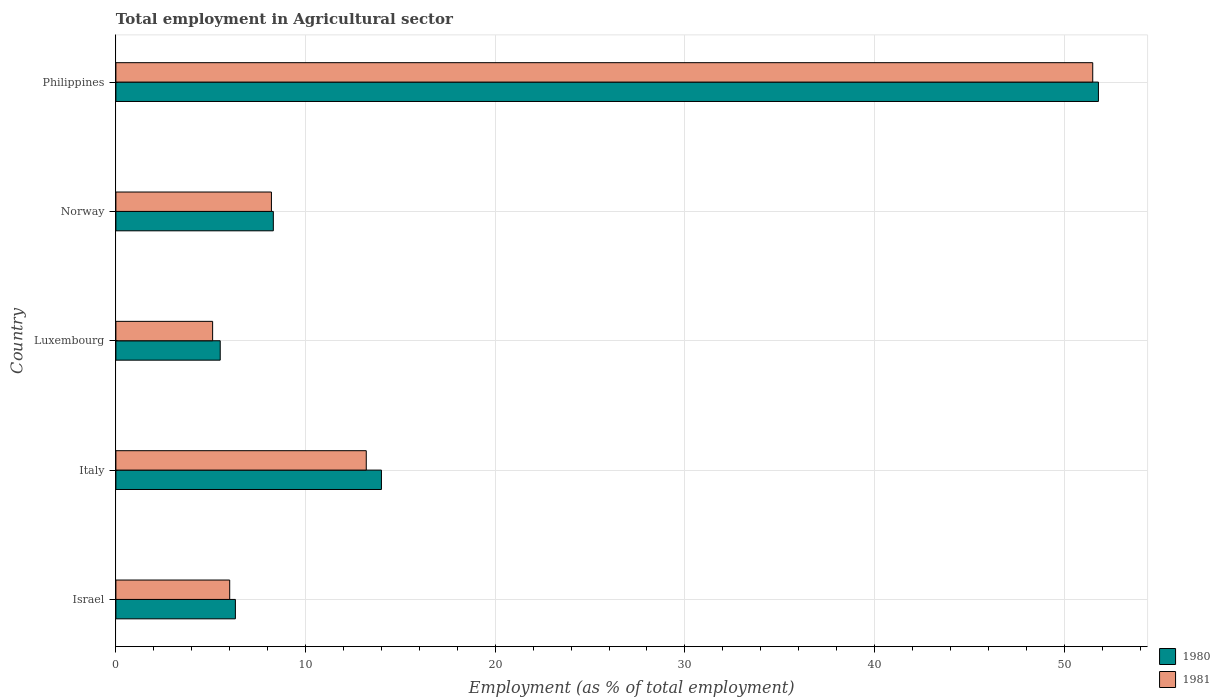How many different coloured bars are there?
Give a very brief answer. 2. How many groups of bars are there?
Provide a short and direct response. 5. Are the number of bars per tick equal to the number of legend labels?
Offer a terse response. Yes. How many bars are there on the 3rd tick from the top?
Ensure brevity in your answer.  2. What is the label of the 2nd group of bars from the top?
Your answer should be compact. Norway. In how many cases, is the number of bars for a given country not equal to the number of legend labels?
Your answer should be very brief. 0. What is the employment in agricultural sector in 1981 in Philippines?
Provide a succinct answer. 51.5. Across all countries, what is the maximum employment in agricultural sector in 1981?
Offer a terse response. 51.5. In which country was the employment in agricultural sector in 1981 maximum?
Offer a terse response. Philippines. In which country was the employment in agricultural sector in 1981 minimum?
Offer a terse response. Luxembourg. What is the total employment in agricultural sector in 1980 in the graph?
Provide a succinct answer. 85.9. What is the difference between the employment in agricultural sector in 1980 in Israel and that in Norway?
Your answer should be compact. -2. What is the difference between the employment in agricultural sector in 1980 in Italy and the employment in agricultural sector in 1981 in Norway?
Keep it short and to the point. 5.8. What is the average employment in agricultural sector in 1981 per country?
Offer a very short reply. 16.8. What is the difference between the employment in agricultural sector in 1981 and employment in agricultural sector in 1980 in Luxembourg?
Make the answer very short. -0.4. What is the ratio of the employment in agricultural sector in 1980 in Italy to that in Luxembourg?
Make the answer very short. 2.55. What is the difference between the highest and the second highest employment in agricultural sector in 1981?
Provide a short and direct response. 38.3. What is the difference between the highest and the lowest employment in agricultural sector in 1980?
Provide a succinct answer. 46.3. In how many countries, is the employment in agricultural sector in 1980 greater than the average employment in agricultural sector in 1980 taken over all countries?
Your answer should be very brief. 1. What does the 1st bar from the top in Israel represents?
Your response must be concise. 1981. What does the 2nd bar from the bottom in Luxembourg represents?
Give a very brief answer. 1981. How many bars are there?
Your answer should be compact. 10. Are all the bars in the graph horizontal?
Make the answer very short. Yes. What is the difference between two consecutive major ticks on the X-axis?
Ensure brevity in your answer.  10. Where does the legend appear in the graph?
Your answer should be very brief. Bottom right. How many legend labels are there?
Offer a terse response. 2. How are the legend labels stacked?
Ensure brevity in your answer.  Vertical. What is the title of the graph?
Provide a short and direct response. Total employment in Agricultural sector. What is the label or title of the X-axis?
Provide a succinct answer. Employment (as % of total employment). What is the Employment (as % of total employment) in 1980 in Israel?
Provide a succinct answer. 6.3. What is the Employment (as % of total employment) in 1980 in Italy?
Your response must be concise. 14. What is the Employment (as % of total employment) in 1981 in Italy?
Ensure brevity in your answer.  13.2. What is the Employment (as % of total employment) in 1981 in Luxembourg?
Provide a succinct answer. 5.1. What is the Employment (as % of total employment) in 1980 in Norway?
Offer a terse response. 8.3. What is the Employment (as % of total employment) in 1981 in Norway?
Make the answer very short. 8.2. What is the Employment (as % of total employment) of 1980 in Philippines?
Give a very brief answer. 51.8. What is the Employment (as % of total employment) in 1981 in Philippines?
Provide a short and direct response. 51.5. Across all countries, what is the maximum Employment (as % of total employment) in 1980?
Give a very brief answer. 51.8. Across all countries, what is the maximum Employment (as % of total employment) in 1981?
Offer a terse response. 51.5. Across all countries, what is the minimum Employment (as % of total employment) of 1981?
Your answer should be compact. 5.1. What is the total Employment (as % of total employment) in 1980 in the graph?
Give a very brief answer. 85.9. What is the total Employment (as % of total employment) in 1981 in the graph?
Provide a succinct answer. 84. What is the difference between the Employment (as % of total employment) of 1980 in Israel and that in Italy?
Your response must be concise. -7.7. What is the difference between the Employment (as % of total employment) of 1981 in Israel and that in Italy?
Your response must be concise. -7.2. What is the difference between the Employment (as % of total employment) in 1980 in Israel and that in Philippines?
Make the answer very short. -45.5. What is the difference between the Employment (as % of total employment) of 1981 in Israel and that in Philippines?
Give a very brief answer. -45.5. What is the difference between the Employment (as % of total employment) of 1980 in Italy and that in Luxembourg?
Offer a very short reply. 8.5. What is the difference between the Employment (as % of total employment) in 1980 in Italy and that in Philippines?
Offer a terse response. -37.8. What is the difference between the Employment (as % of total employment) of 1981 in Italy and that in Philippines?
Provide a succinct answer. -38.3. What is the difference between the Employment (as % of total employment) in 1980 in Luxembourg and that in Norway?
Offer a terse response. -2.8. What is the difference between the Employment (as % of total employment) of 1980 in Luxembourg and that in Philippines?
Your answer should be compact. -46.3. What is the difference between the Employment (as % of total employment) in 1981 in Luxembourg and that in Philippines?
Make the answer very short. -46.4. What is the difference between the Employment (as % of total employment) of 1980 in Norway and that in Philippines?
Your answer should be compact. -43.5. What is the difference between the Employment (as % of total employment) in 1981 in Norway and that in Philippines?
Your answer should be compact. -43.3. What is the difference between the Employment (as % of total employment) of 1980 in Israel and the Employment (as % of total employment) of 1981 in Luxembourg?
Ensure brevity in your answer.  1.2. What is the difference between the Employment (as % of total employment) of 1980 in Israel and the Employment (as % of total employment) of 1981 in Norway?
Offer a very short reply. -1.9. What is the difference between the Employment (as % of total employment) of 1980 in Israel and the Employment (as % of total employment) of 1981 in Philippines?
Ensure brevity in your answer.  -45.2. What is the difference between the Employment (as % of total employment) of 1980 in Italy and the Employment (as % of total employment) of 1981 in Norway?
Provide a short and direct response. 5.8. What is the difference between the Employment (as % of total employment) in 1980 in Italy and the Employment (as % of total employment) in 1981 in Philippines?
Keep it short and to the point. -37.5. What is the difference between the Employment (as % of total employment) of 1980 in Luxembourg and the Employment (as % of total employment) of 1981 in Norway?
Ensure brevity in your answer.  -2.7. What is the difference between the Employment (as % of total employment) in 1980 in Luxembourg and the Employment (as % of total employment) in 1981 in Philippines?
Provide a short and direct response. -46. What is the difference between the Employment (as % of total employment) of 1980 in Norway and the Employment (as % of total employment) of 1981 in Philippines?
Keep it short and to the point. -43.2. What is the average Employment (as % of total employment) of 1980 per country?
Ensure brevity in your answer.  17.18. What is the difference between the Employment (as % of total employment) of 1980 and Employment (as % of total employment) of 1981 in Norway?
Make the answer very short. 0.1. What is the difference between the Employment (as % of total employment) in 1980 and Employment (as % of total employment) in 1981 in Philippines?
Ensure brevity in your answer.  0.3. What is the ratio of the Employment (as % of total employment) in 1980 in Israel to that in Italy?
Ensure brevity in your answer.  0.45. What is the ratio of the Employment (as % of total employment) of 1981 in Israel to that in Italy?
Your answer should be very brief. 0.45. What is the ratio of the Employment (as % of total employment) of 1980 in Israel to that in Luxembourg?
Ensure brevity in your answer.  1.15. What is the ratio of the Employment (as % of total employment) in 1981 in Israel to that in Luxembourg?
Offer a very short reply. 1.18. What is the ratio of the Employment (as % of total employment) in 1980 in Israel to that in Norway?
Provide a short and direct response. 0.76. What is the ratio of the Employment (as % of total employment) of 1981 in Israel to that in Norway?
Your answer should be compact. 0.73. What is the ratio of the Employment (as % of total employment) of 1980 in Israel to that in Philippines?
Offer a very short reply. 0.12. What is the ratio of the Employment (as % of total employment) of 1981 in Israel to that in Philippines?
Make the answer very short. 0.12. What is the ratio of the Employment (as % of total employment) in 1980 in Italy to that in Luxembourg?
Your response must be concise. 2.55. What is the ratio of the Employment (as % of total employment) in 1981 in Italy to that in Luxembourg?
Provide a succinct answer. 2.59. What is the ratio of the Employment (as % of total employment) of 1980 in Italy to that in Norway?
Give a very brief answer. 1.69. What is the ratio of the Employment (as % of total employment) of 1981 in Italy to that in Norway?
Offer a very short reply. 1.61. What is the ratio of the Employment (as % of total employment) in 1980 in Italy to that in Philippines?
Your answer should be compact. 0.27. What is the ratio of the Employment (as % of total employment) of 1981 in Italy to that in Philippines?
Make the answer very short. 0.26. What is the ratio of the Employment (as % of total employment) in 1980 in Luxembourg to that in Norway?
Provide a succinct answer. 0.66. What is the ratio of the Employment (as % of total employment) of 1981 in Luxembourg to that in Norway?
Your answer should be compact. 0.62. What is the ratio of the Employment (as % of total employment) of 1980 in Luxembourg to that in Philippines?
Provide a short and direct response. 0.11. What is the ratio of the Employment (as % of total employment) of 1981 in Luxembourg to that in Philippines?
Offer a very short reply. 0.1. What is the ratio of the Employment (as % of total employment) of 1980 in Norway to that in Philippines?
Your answer should be very brief. 0.16. What is the ratio of the Employment (as % of total employment) in 1981 in Norway to that in Philippines?
Provide a succinct answer. 0.16. What is the difference between the highest and the second highest Employment (as % of total employment) of 1980?
Ensure brevity in your answer.  37.8. What is the difference between the highest and the second highest Employment (as % of total employment) of 1981?
Offer a terse response. 38.3. What is the difference between the highest and the lowest Employment (as % of total employment) in 1980?
Your answer should be very brief. 46.3. What is the difference between the highest and the lowest Employment (as % of total employment) in 1981?
Make the answer very short. 46.4. 